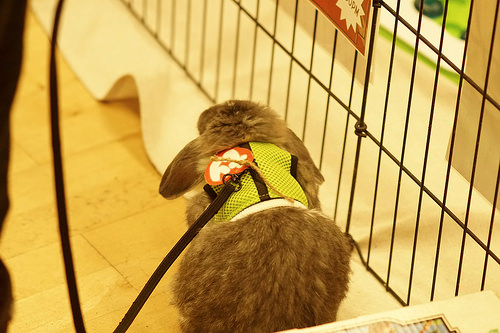<image>
Can you confirm if the rabbit is on the cage? No. The rabbit is not positioned on the cage. They may be near each other, but the rabbit is not supported by or resting on top of the cage. Is there a bunny on the gate? No. The bunny is not positioned on the gate. They may be near each other, but the bunny is not supported by or resting on top of the gate. Where is the bunny in relation to the leash? Is it in the leash? Yes. The bunny is contained within or inside the leash, showing a containment relationship. 